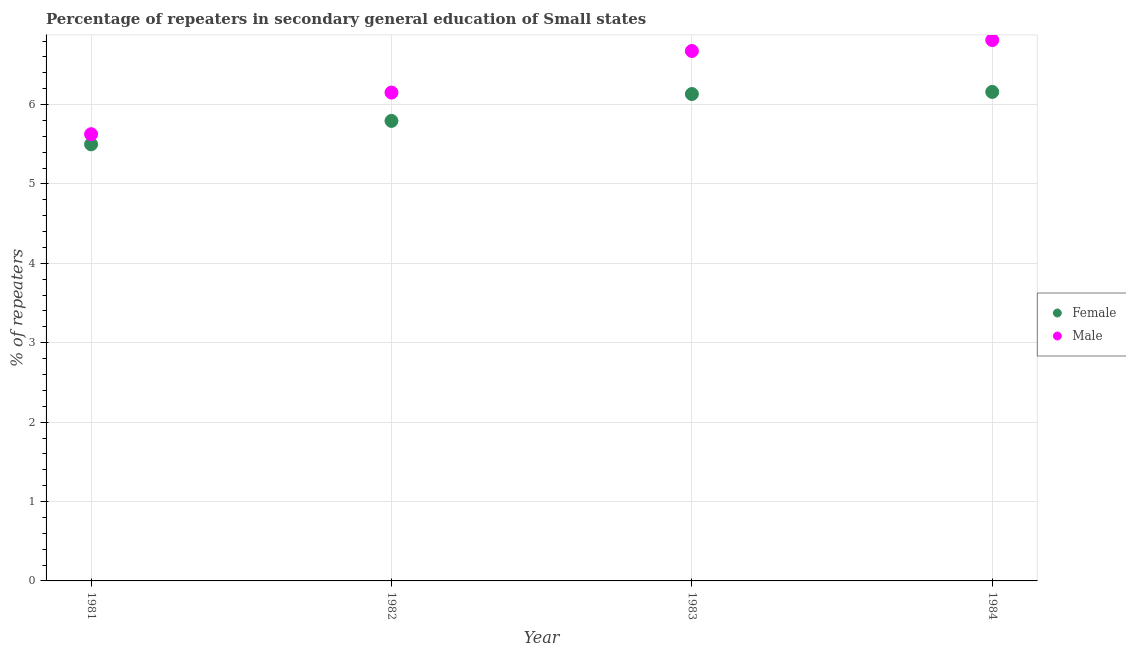What is the percentage of female repeaters in 1982?
Offer a terse response. 5.79. Across all years, what is the maximum percentage of male repeaters?
Give a very brief answer. 6.81. Across all years, what is the minimum percentage of female repeaters?
Your answer should be very brief. 5.5. In which year was the percentage of male repeaters maximum?
Your answer should be compact. 1984. In which year was the percentage of male repeaters minimum?
Provide a short and direct response. 1981. What is the total percentage of male repeaters in the graph?
Give a very brief answer. 25.27. What is the difference between the percentage of female repeaters in 1982 and that in 1984?
Give a very brief answer. -0.37. What is the difference between the percentage of male repeaters in 1983 and the percentage of female repeaters in 1984?
Your response must be concise. 0.52. What is the average percentage of male repeaters per year?
Offer a very short reply. 6.32. In the year 1983, what is the difference between the percentage of female repeaters and percentage of male repeaters?
Your answer should be very brief. -0.54. What is the ratio of the percentage of male repeaters in 1981 to that in 1982?
Provide a short and direct response. 0.91. What is the difference between the highest and the second highest percentage of male repeaters?
Your response must be concise. 0.14. What is the difference between the highest and the lowest percentage of female repeaters?
Provide a short and direct response. 0.66. Is the sum of the percentage of female repeaters in 1981 and 1982 greater than the maximum percentage of male repeaters across all years?
Your answer should be very brief. Yes. Is the percentage of female repeaters strictly greater than the percentage of male repeaters over the years?
Your answer should be very brief. No. Is the percentage of male repeaters strictly less than the percentage of female repeaters over the years?
Provide a short and direct response. No. How many dotlines are there?
Give a very brief answer. 2. How many years are there in the graph?
Ensure brevity in your answer.  4. Does the graph contain grids?
Offer a very short reply. Yes. Where does the legend appear in the graph?
Your response must be concise. Center right. What is the title of the graph?
Offer a very short reply. Percentage of repeaters in secondary general education of Small states. Does "Private consumption" appear as one of the legend labels in the graph?
Provide a short and direct response. No. What is the label or title of the Y-axis?
Offer a very short reply. % of repeaters. What is the % of repeaters of Female in 1981?
Your response must be concise. 5.5. What is the % of repeaters of Male in 1981?
Provide a short and direct response. 5.63. What is the % of repeaters of Female in 1982?
Your response must be concise. 5.79. What is the % of repeaters of Male in 1982?
Your response must be concise. 6.15. What is the % of repeaters in Female in 1983?
Keep it short and to the point. 6.13. What is the % of repeaters in Male in 1983?
Offer a terse response. 6.68. What is the % of repeaters in Female in 1984?
Offer a very short reply. 6.16. What is the % of repeaters of Male in 1984?
Give a very brief answer. 6.81. Across all years, what is the maximum % of repeaters in Female?
Provide a short and direct response. 6.16. Across all years, what is the maximum % of repeaters in Male?
Your response must be concise. 6.81. Across all years, what is the minimum % of repeaters in Female?
Ensure brevity in your answer.  5.5. Across all years, what is the minimum % of repeaters in Male?
Your answer should be very brief. 5.63. What is the total % of repeaters in Female in the graph?
Your response must be concise. 23.59. What is the total % of repeaters of Male in the graph?
Offer a very short reply. 25.27. What is the difference between the % of repeaters in Female in 1981 and that in 1982?
Offer a very short reply. -0.29. What is the difference between the % of repeaters in Male in 1981 and that in 1982?
Offer a very short reply. -0.52. What is the difference between the % of repeaters in Female in 1981 and that in 1983?
Provide a short and direct response. -0.63. What is the difference between the % of repeaters of Male in 1981 and that in 1983?
Keep it short and to the point. -1.05. What is the difference between the % of repeaters of Female in 1981 and that in 1984?
Offer a very short reply. -0.66. What is the difference between the % of repeaters of Male in 1981 and that in 1984?
Your answer should be compact. -1.19. What is the difference between the % of repeaters in Female in 1982 and that in 1983?
Ensure brevity in your answer.  -0.34. What is the difference between the % of repeaters of Male in 1982 and that in 1983?
Provide a succinct answer. -0.52. What is the difference between the % of repeaters of Female in 1982 and that in 1984?
Your answer should be compact. -0.37. What is the difference between the % of repeaters in Male in 1982 and that in 1984?
Ensure brevity in your answer.  -0.66. What is the difference between the % of repeaters of Female in 1983 and that in 1984?
Ensure brevity in your answer.  -0.03. What is the difference between the % of repeaters of Male in 1983 and that in 1984?
Provide a short and direct response. -0.14. What is the difference between the % of repeaters in Female in 1981 and the % of repeaters in Male in 1982?
Provide a short and direct response. -0.65. What is the difference between the % of repeaters in Female in 1981 and the % of repeaters in Male in 1983?
Keep it short and to the point. -1.18. What is the difference between the % of repeaters of Female in 1981 and the % of repeaters of Male in 1984?
Keep it short and to the point. -1.31. What is the difference between the % of repeaters of Female in 1982 and the % of repeaters of Male in 1983?
Keep it short and to the point. -0.88. What is the difference between the % of repeaters in Female in 1982 and the % of repeaters in Male in 1984?
Provide a succinct answer. -1.02. What is the difference between the % of repeaters in Female in 1983 and the % of repeaters in Male in 1984?
Your answer should be very brief. -0.68. What is the average % of repeaters in Female per year?
Provide a short and direct response. 5.9. What is the average % of repeaters of Male per year?
Provide a succinct answer. 6.32. In the year 1981, what is the difference between the % of repeaters in Female and % of repeaters in Male?
Provide a short and direct response. -0.13. In the year 1982, what is the difference between the % of repeaters of Female and % of repeaters of Male?
Your response must be concise. -0.36. In the year 1983, what is the difference between the % of repeaters in Female and % of repeaters in Male?
Give a very brief answer. -0.54. In the year 1984, what is the difference between the % of repeaters of Female and % of repeaters of Male?
Your answer should be very brief. -0.65. What is the ratio of the % of repeaters in Female in 1981 to that in 1982?
Offer a terse response. 0.95. What is the ratio of the % of repeaters in Male in 1981 to that in 1982?
Your answer should be compact. 0.91. What is the ratio of the % of repeaters of Female in 1981 to that in 1983?
Make the answer very short. 0.9. What is the ratio of the % of repeaters of Male in 1981 to that in 1983?
Offer a very short reply. 0.84. What is the ratio of the % of repeaters of Female in 1981 to that in 1984?
Give a very brief answer. 0.89. What is the ratio of the % of repeaters in Male in 1981 to that in 1984?
Provide a short and direct response. 0.83. What is the ratio of the % of repeaters of Female in 1982 to that in 1983?
Offer a very short reply. 0.94. What is the ratio of the % of repeaters of Male in 1982 to that in 1983?
Your answer should be compact. 0.92. What is the ratio of the % of repeaters of Female in 1982 to that in 1984?
Your answer should be compact. 0.94. What is the ratio of the % of repeaters of Male in 1982 to that in 1984?
Provide a succinct answer. 0.9. What is the ratio of the % of repeaters in Female in 1983 to that in 1984?
Keep it short and to the point. 1. What is the ratio of the % of repeaters in Male in 1983 to that in 1984?
Make the answer very short. 0.98. What is the difference between the highest and the second highest % of repeaters in Female?
Provide a succinct answer. 0.03. What is the difference between the highest and the second highest % of repeaters of Male?
Provide a short and direct response. 0.14. What is the difference between the highest and the lowest % of repeaters of Female?
Make the answer very short. 0.66. What is the difference between the highest and the lowest % of repeaters in Male?
Your answer should be compact. 1.19. 